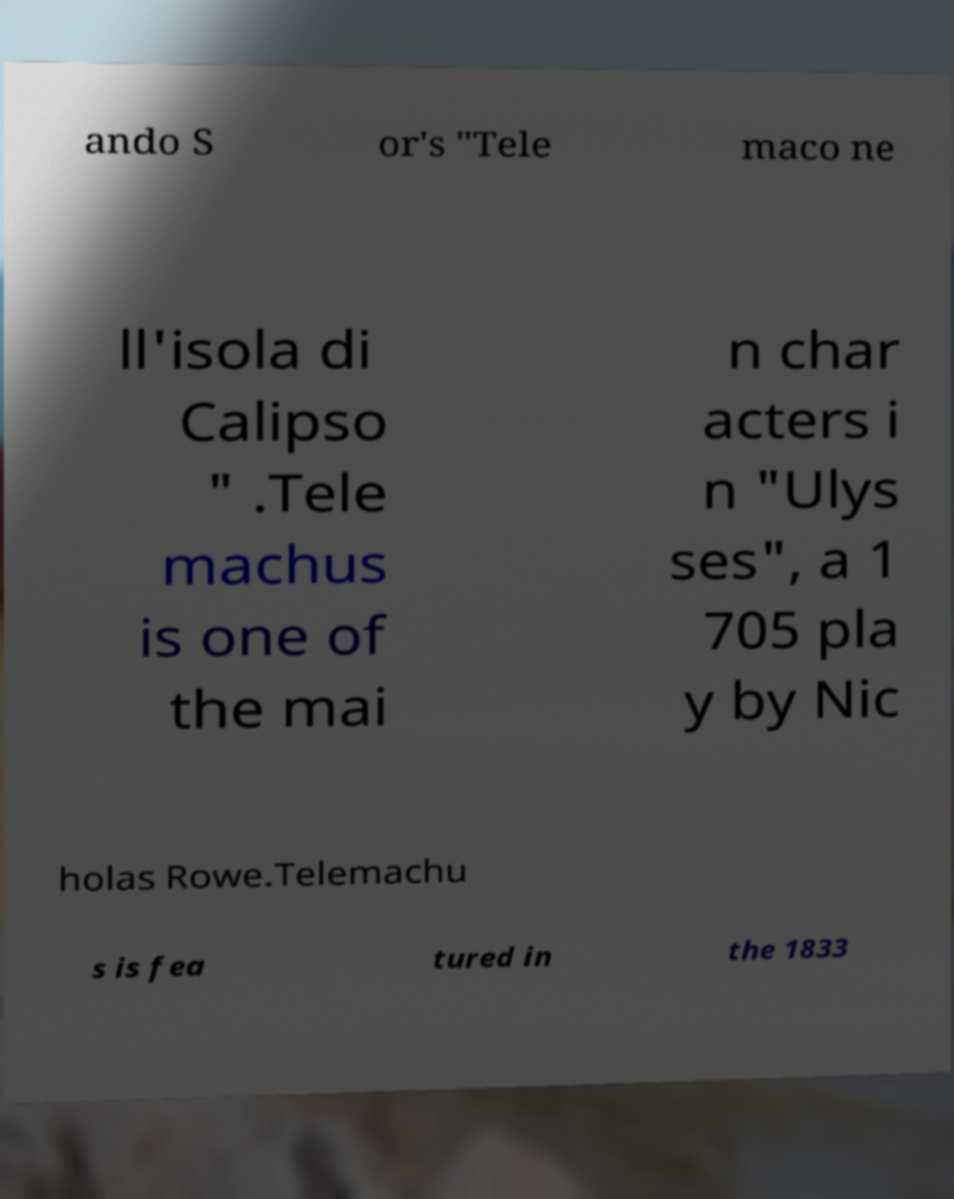What messages or text are displayed in this image? I need them in a readable, typed format. ando S or's "Tele maco ne ll'isola di Calipso " .Tele machus is one of the mai n char acters i n "Ulys ses", a 1 705 pla y by Nic holas Rowe.Telemachu s is fea tured in the 1833 